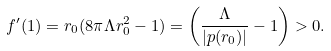<formula> <loc_0><loc_0><loc_500><loc_500>f ^ { \prime } ( 1 ) = r _ { 0 } ( 8 \pi \Lambda r _ { 0 } ^ { 2 } - 1 ) = \left ( \frac { \Lambda } { | p ( r _ { 0 } ) | } - 1 \right ) > 0 .</formula> 